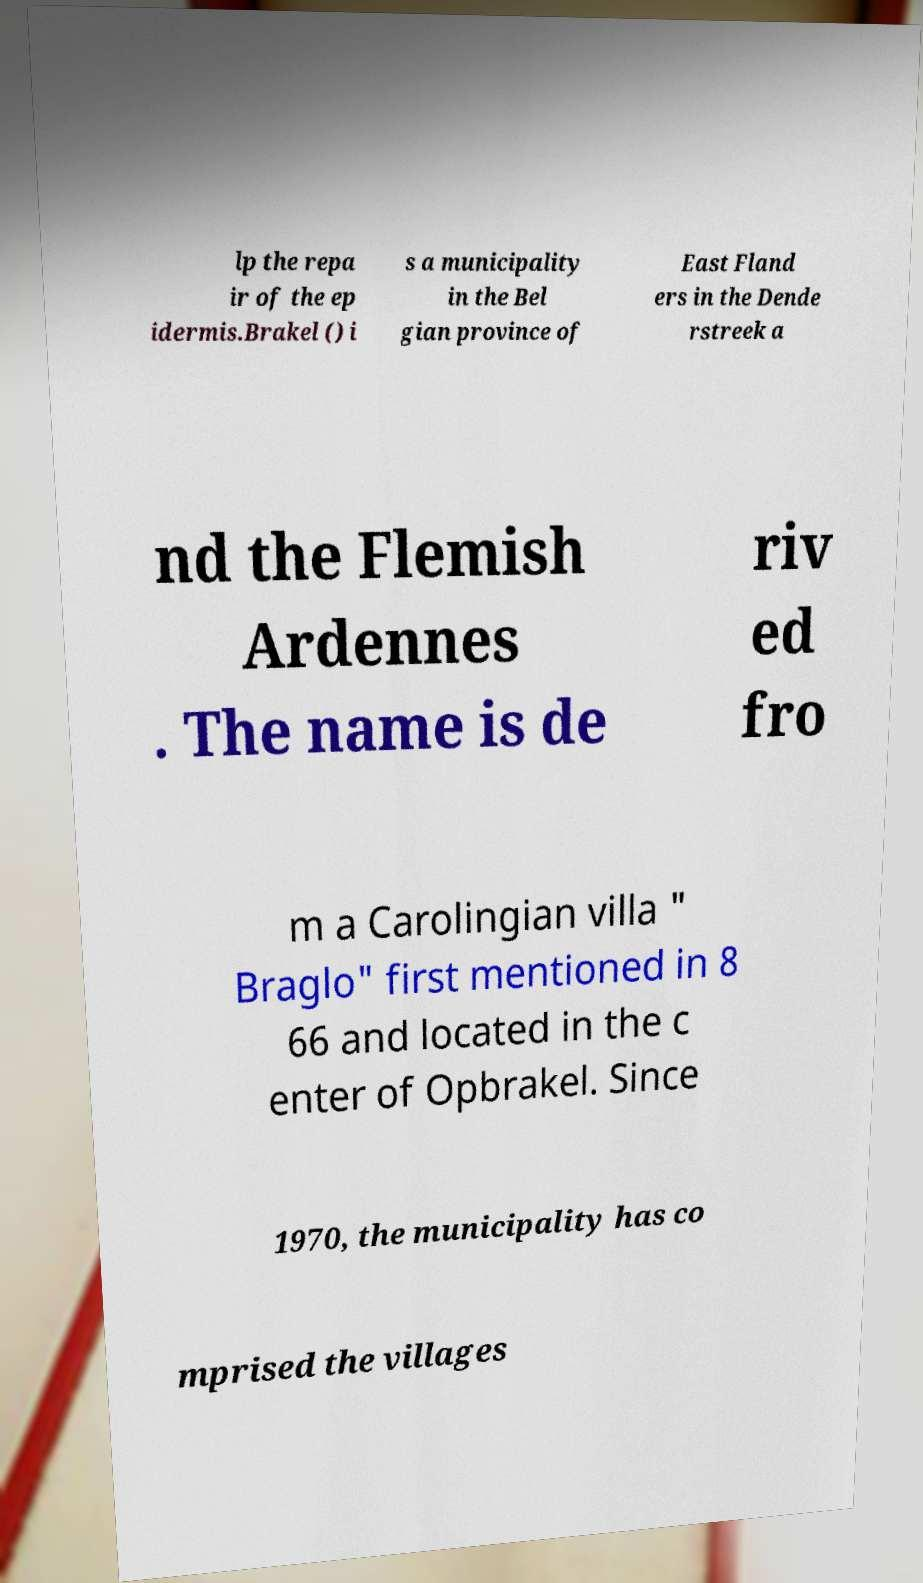Could you assist in decoding the text presented in this image and type it out clearly? lp the repa ir of the ep idermis.Brakel () i s a municipality in the Bel gian province of East Fland ers in the Dende rstreek a nd the Flemish Ardennes . The name is de riv ed fro m a Carolingian villa " Braglo" first mentioned in 8 66 and located in the c enter of Opbrakel. Since 1970, the municipality has co mprised the villages 